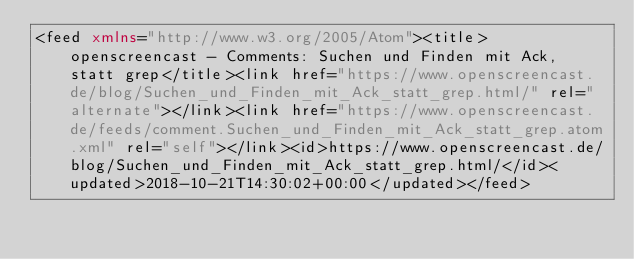Convert code to text. <code><loc_0><loc_0><loc_500><loc_500><_XML_><feed xmlns="http://www.w3.org/2005/Atom"><title>openscreencast - Comments: Suchen und Finden mit Ack, statt grep</title><link href="https://www.openscreencast.de/blog/Suchen_und_Finden_mit_Ack_statt_grep.html/" rel="alternate"></link><link href="https://www.openscreencast.de/feeds/comment.Suchen_und_Finden_mit_Ack_statt_grep.atom.xml" rel="self"></link><id>https://www.openscreencast.de/blog/Suchen_und_Finden_mit_Ack_statt_grep.html/</id><updated>2018-10-21T14:30:02+00:00</updated></feed></code> 